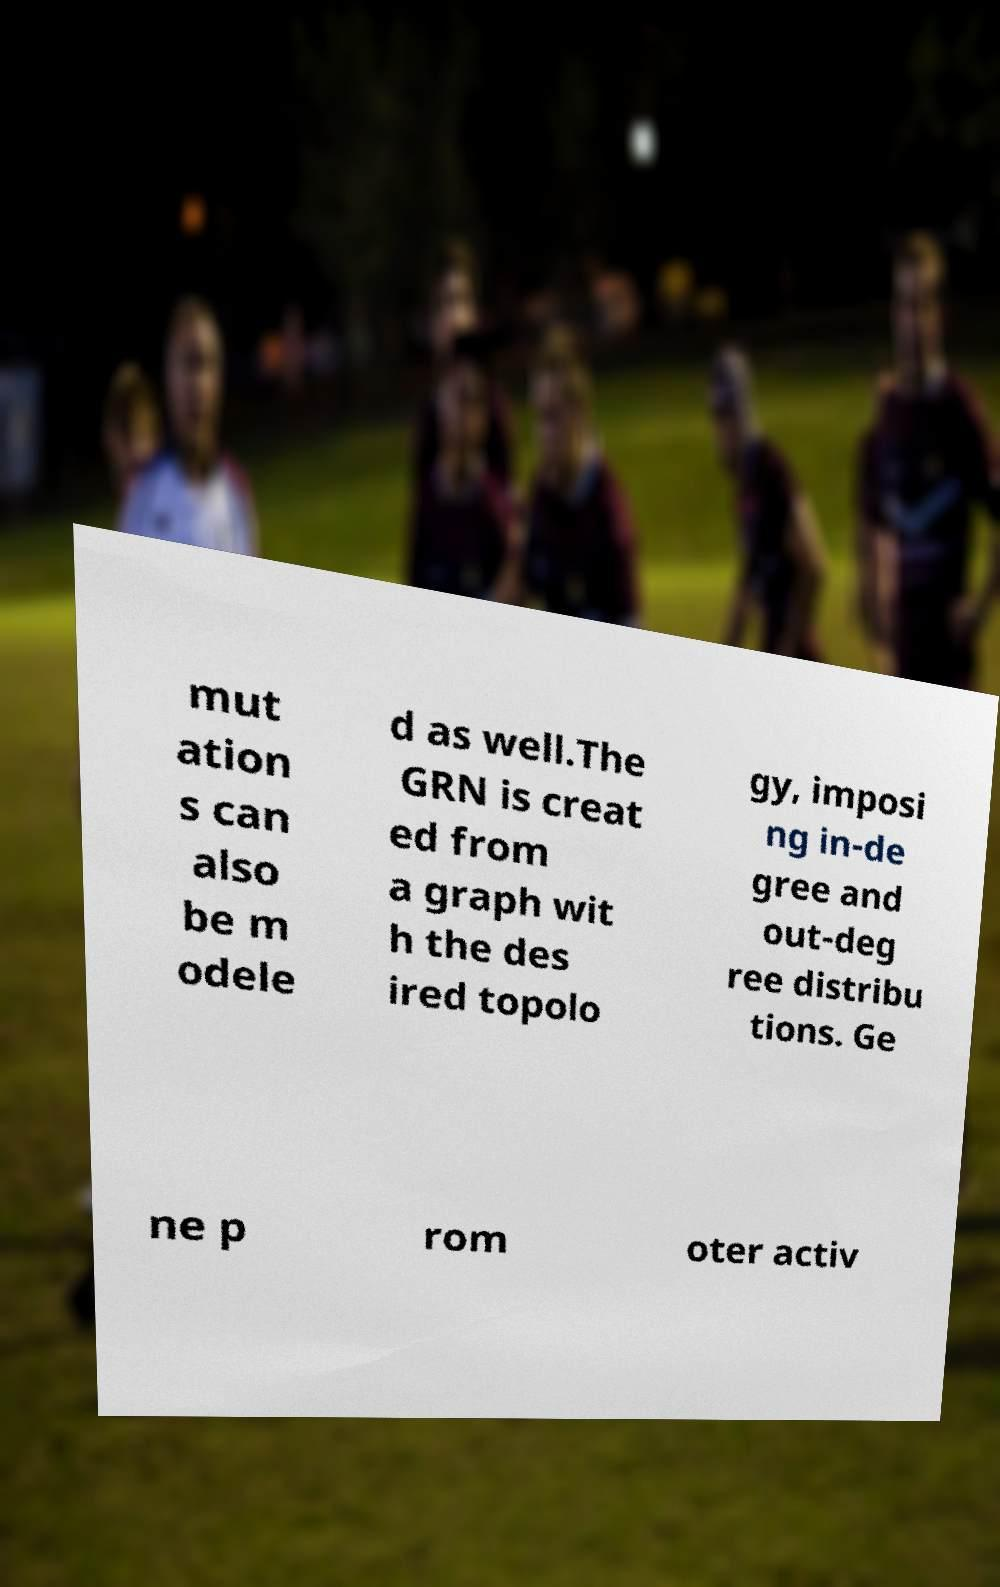Please read and relay the text visible in this image. What does it say? mut ation s can also be m odele d as well.The GRN is creat ed from a graph wit h the des ired topolo gy, imposi ng in-de gree and out-deg ree distribu tions. Ge ne p rom oter activ 